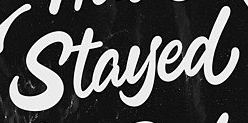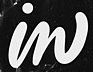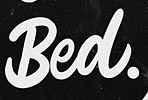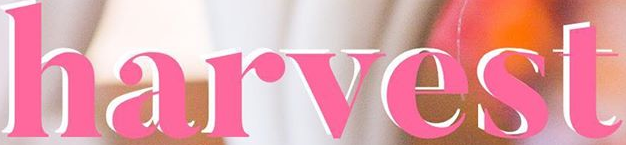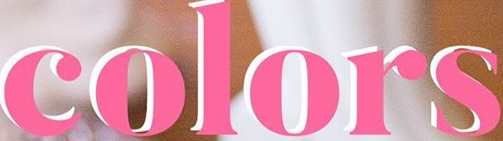Read the text from these images in sequence, separated by a semicolon. Stayed; in; Bed.; harvest; colors 